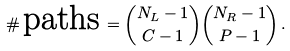<formula> <loc_0><loc_0><loc_500><loc_500>\# \, \text {paths} \, = \binom { N _ { L } - 1 } { C - 1 } \binom { N _ { R } - 1 } { P - 1 } \, .</formula> 